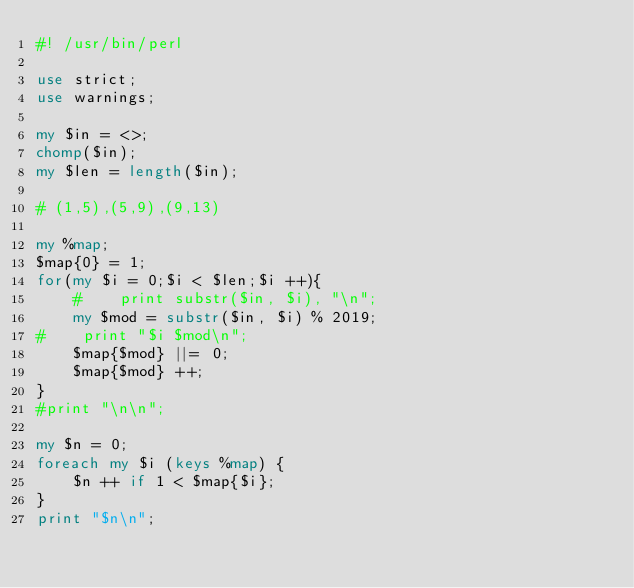Convert code to text. <code><loc_0><loc_0><loc_500><loc_500><_Perl_>#! /usr/bin/perl

use strict;
use warnings;

my $in = <>;
chomp($in);
my $len = length($in);

# (1,5),(5,9),(9,13)

my %map;
$map{0} = 1;
for(my $i = 0;$i < $len;$i ++){
    #    print substr($in, $i), "\n";
    my $mod = substr($in, $i) % 2019;
#    print "$i $mod\n";
    $map{$mod} ||= 0;
    $map{$mod} ++;
}
#print "\n\n";

my $n = 0;
foreach my $i (keys %map) {
    $n ++ if 1 < $map{$i};
}
print "$n\n";
</code> 